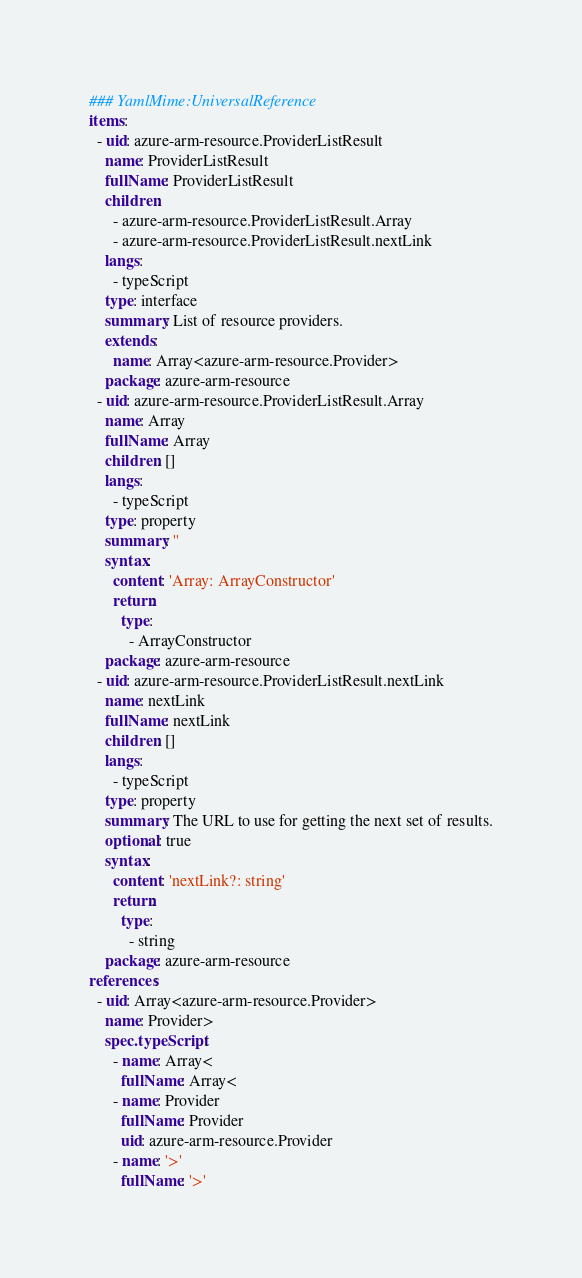Convert code to text. <code><loc_0><loc_0><loc_500><loc_500><_YAML_>### YamlMime:UniversalReference
items:
  - uid: azure-arm-resource.ProviderListResult
    name: ProviderListResult
    fullName: ProviderListResult
    children:
      - azure-arm-resource.ProviderListResult.Array
      - azure-arm-resource.ProviderListResult.nextLink
    langs:
      - typeScript
    type: interface
    summary: List of resource providers.
    extends:
      name: Array<azure-arm-resource.Provider>
    package: azure-arm-resource
  - uid: azure-arm-resource.ProviderListResult.Array
    name: Array
    fullName: Array
    children: []
    langs:
      - typeScript
    type: property
    summary: ''
    syntax:
      content: 'Array: ArrayConstructor'
      return:
        type:
          - ArrayConstructor
    package: azure-arm-resource
  - uid: azure-arm-resource.ProviderListResult.nextLink
    name: nextLink
    fullName: nextLink
    children: []
    langs:
      - typeScript
    type: property
    summary: The URL to use for getting the next set of results.
    optional: true
    syntax:
      content: 'nextLink?: string'
      return:
        type:
          - string
    package: azure-arm-resource
references:
  - uid: Array<azure-arm-resource.Provider>
    name: Provider>
    spec.typeScript:
      - name: Array<
        fullName: Array<
      - name: Provider
        fullName: Provider
        uid: azure-arm-resource.Provider
      - name: '>'
        fullName: '>'
</code> 